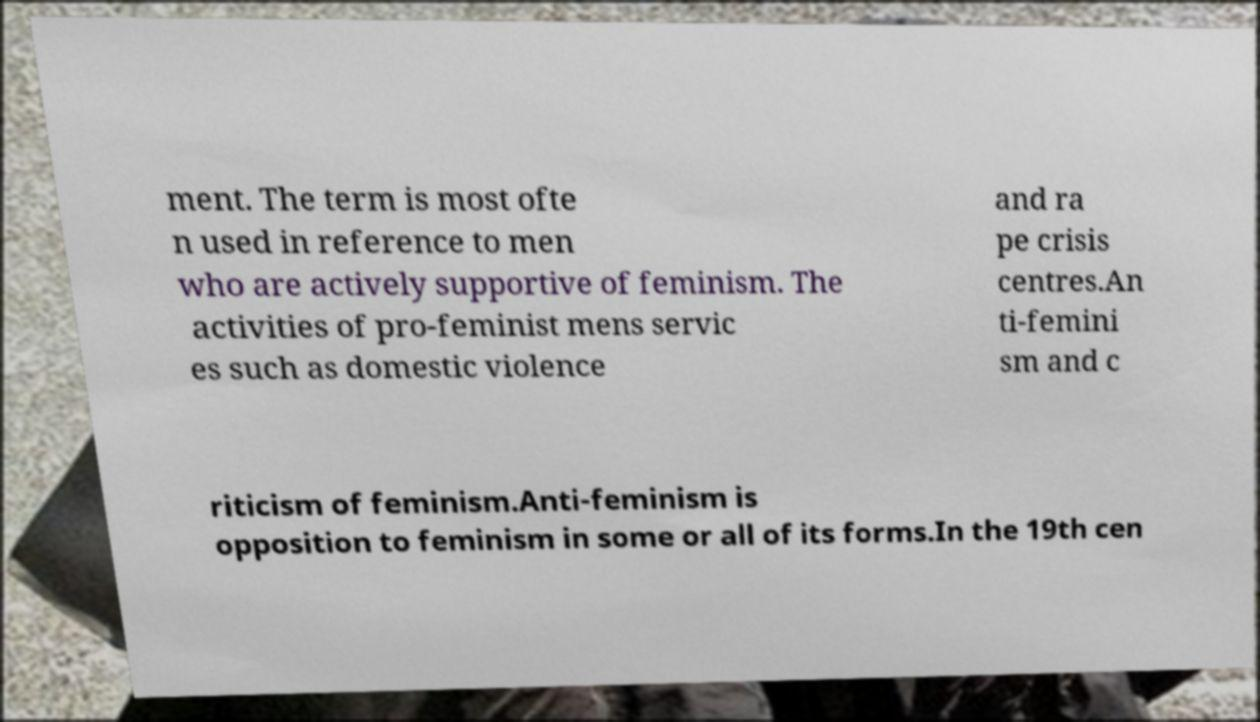Please read and relay the text visible in this image. What does it say? ment. The term is most ofte n used in reference to men who are actively supportive of feminism. The activities of pro-feminist mens servic es such as domestic violence and ra pe crisis centres.An ti-femini sm and c riticism of feminism.Anti-feminism is opposition to feminism in some or all of its forms.In the 19th cen 